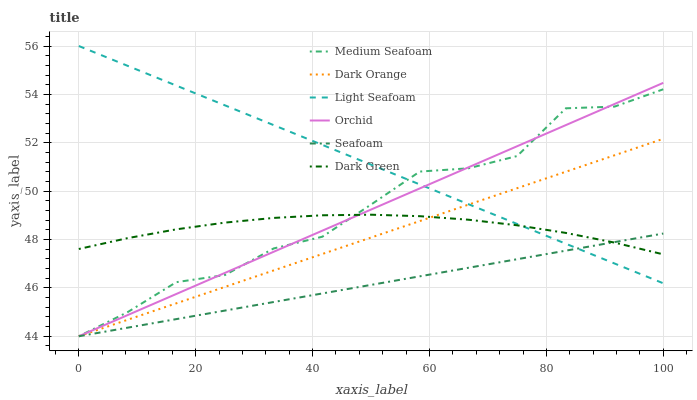Does Dark Orange have the minimum area under the curve?
Answer yes or no. No. Does Dark Orange have the maximum area under the curve?
Answer yes or no. No. Is Seafoam the smoothest?
Answer yes or no. No. Is Seafoam the roughest?
Answer yes or no. No. Does Light Seafoam have the lowest value?
Answer yes or no. No. Does Dark Orange have the highest value?
Answer yes or no. No. 